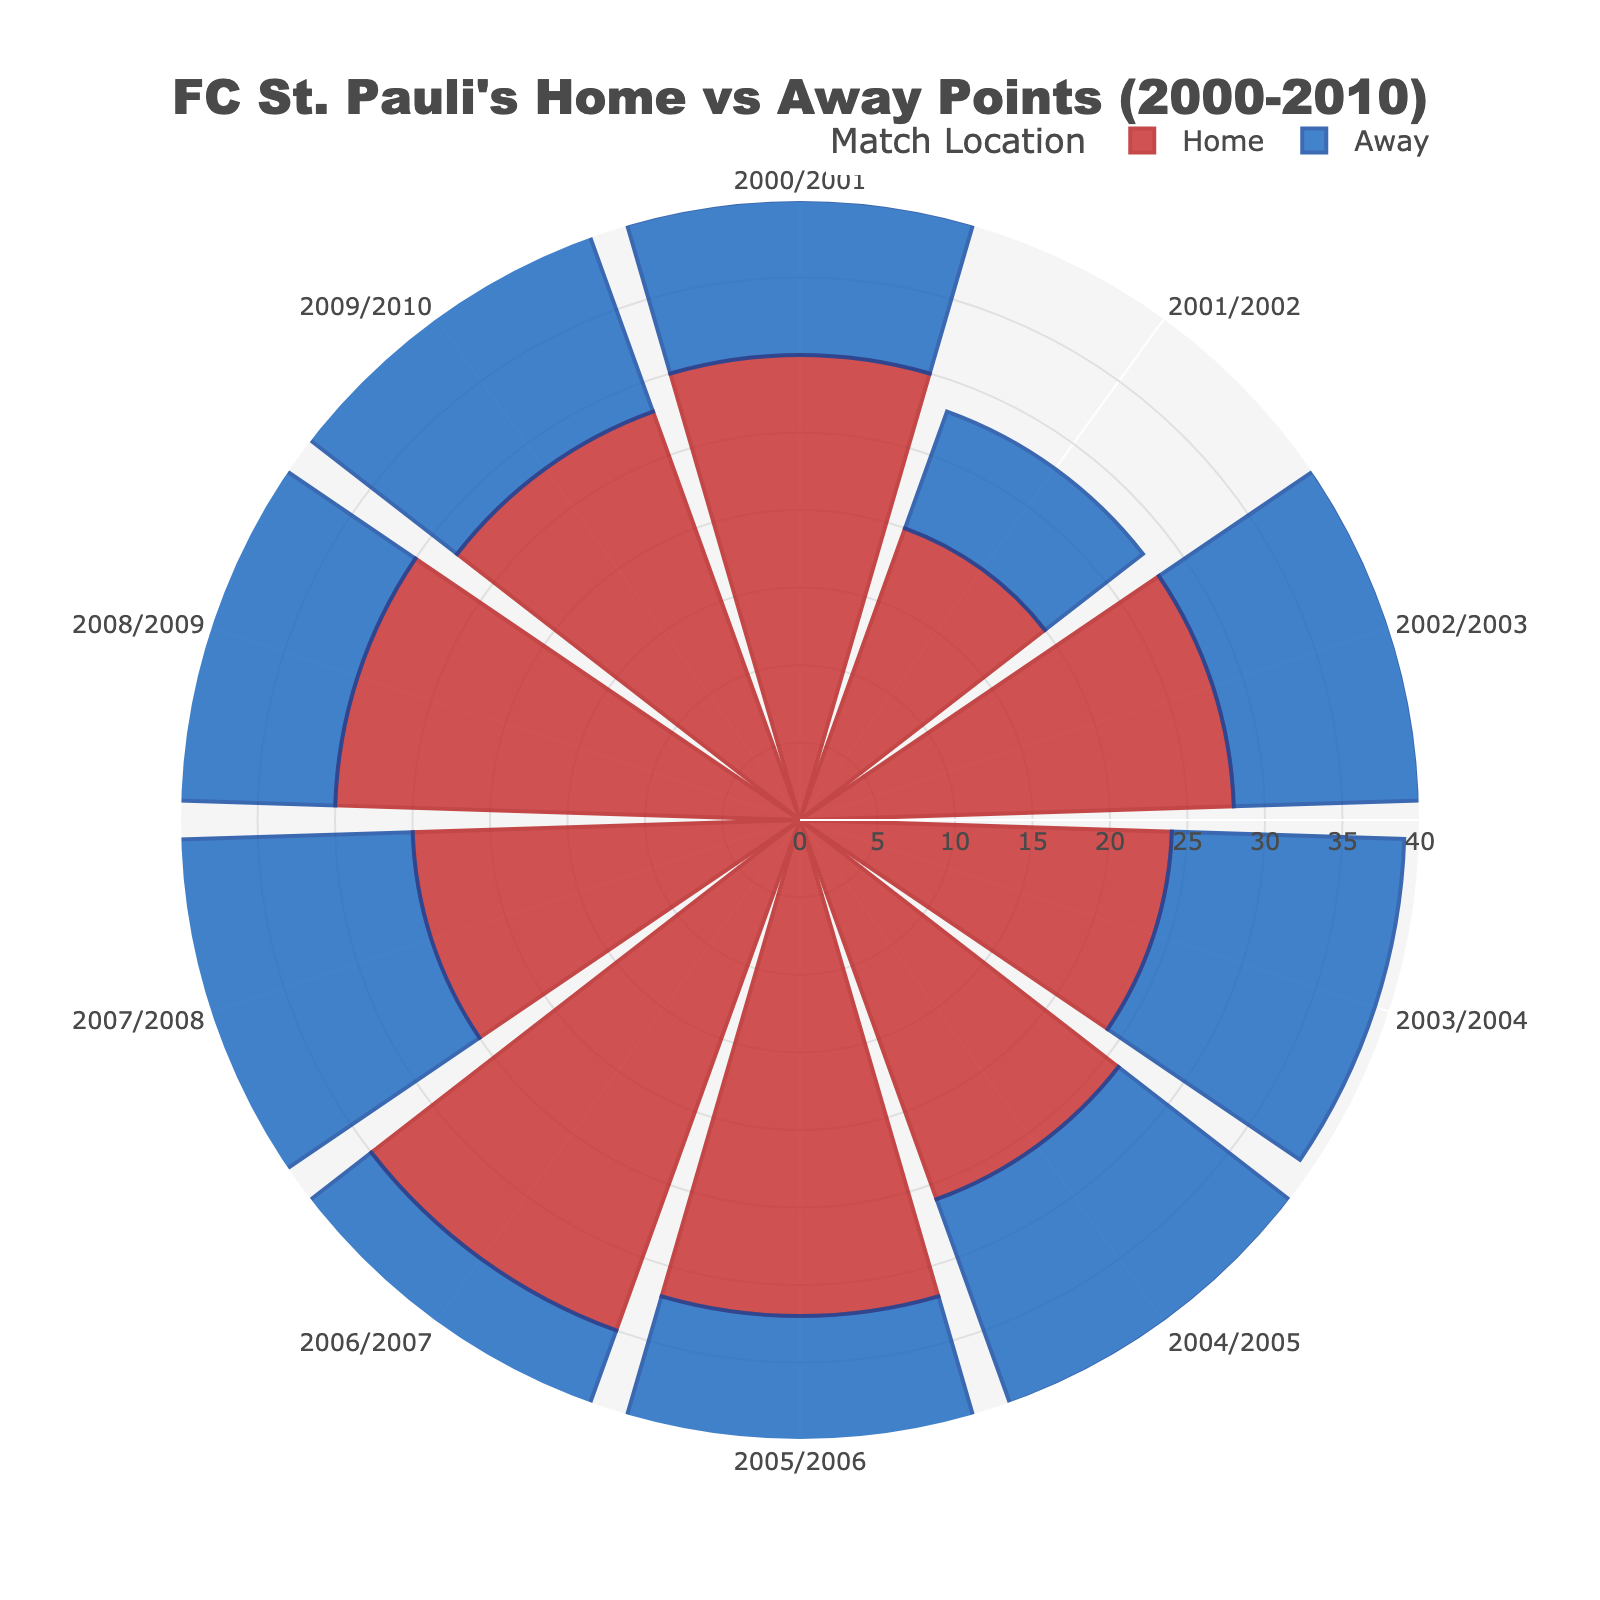Which season did FC St. Pauli accumulate the highest points in home matches? The figure shows the radial distance representing points for different seasons. The season with the longest radial distance (highest number) for home matches is 2006/2007.
Answer: 2006/2007 Which season recorded the fewest points in away matches? The radial distance corresponding to away points for each season is visible. The smallest distance is seen for the 2001/2002 season.
Answer: 2001/2002 What is the difference in home and away points for the 2009/2010 season? In 2009/2010, home points are 28 and away points are 20. The difference is 28 - 20 = 8.
Answer: 8 In how many seasons did FC St. Pauli earn more than 30 points in home matches? The radial distances for home points that exceed 30 can be observed for the seasons 2005/2006 and 2006/2007. Thus, there are 2 seasons.
Answer: 2 Which season saw the closest point tally between home and away matches? To find the smallest difference, we look for seasons where the radial distances for home and away are most similar. The closest point tallies are observed in 2009/2010, where the difference is 8 points (28 home - 20 away).
Answer: 2009/2010 How many total points did FC St. Pauli earn in home games over the seasons displayed? Sum the radial distances for all home points: 30 + 20 + 28 + 24 + 26 + 32 + 35 + 25 + 30 + 28 = 278.
Answer: 278 Which season had a higher point tally in away games compared to home games? Only compare the length of radial distances of points for home and away games per season. No season displayed a higher away point tally compared to home points.
Answer: None What is the cumulative difference between home and away points in the 2003/2004 and 2004/2005 seasons? Sum the differences for each year: (24 - 15) + (26 - 14) = 9 + 12 = 21.
Answer: 21 What color represents home matches on the chart? The radial plots' colors are visible. The home matches are represented using shades of red.
Answer: Red How many more points did FC St. Pauli earn at home compared to away in the 2006/2007 season? For 2006/2007, subtract the away points from the home points: 35 - 15 = 20.
Answer: 20 